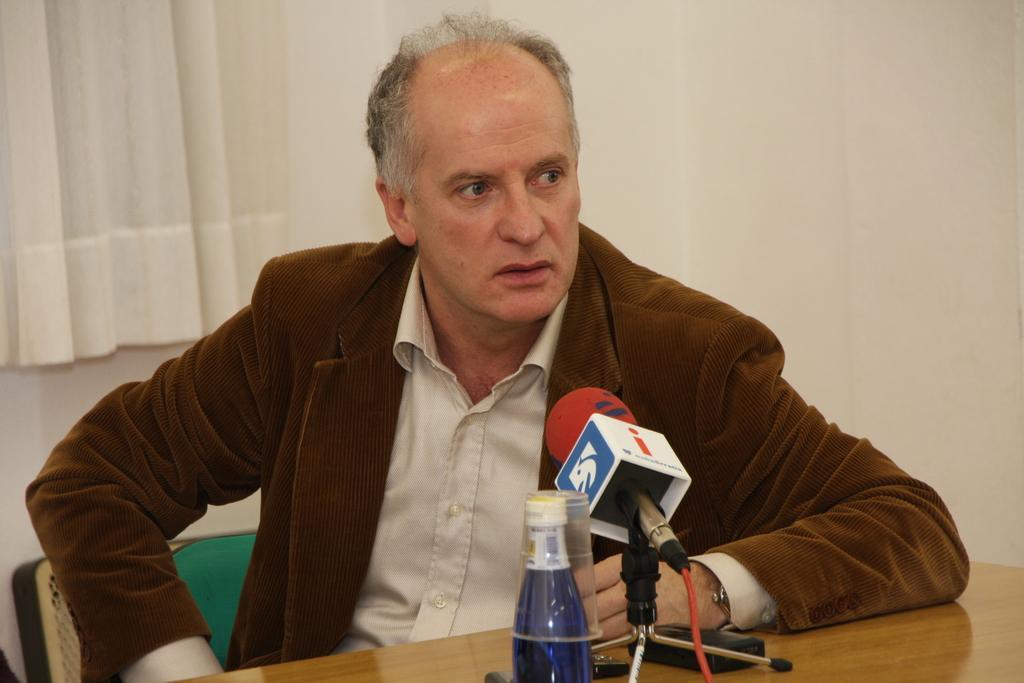Please provide a concise description of this image. In this picture we can see a man. This is table. On the table there is a bottle and this is mike. On the background there is a wall and this is curtain. 